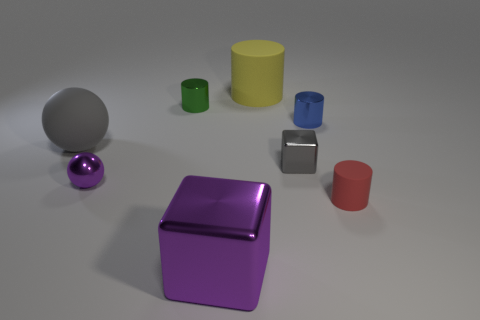Add 1 large matte things. How many objects exist? 9 Subtract all balls. How many objects are left? 6 Subtract 0 brown cubes. How many objects are left? 8 Subtract all large red matte things. Subtract all small red rubber objects. How many objects are left? 7 Add 5 tiny gray shiny objects. How many tiny gray shiny objects are left? 6 Add 4 large blue shiny spheres. How many large blue shiny spheres exist? 4 